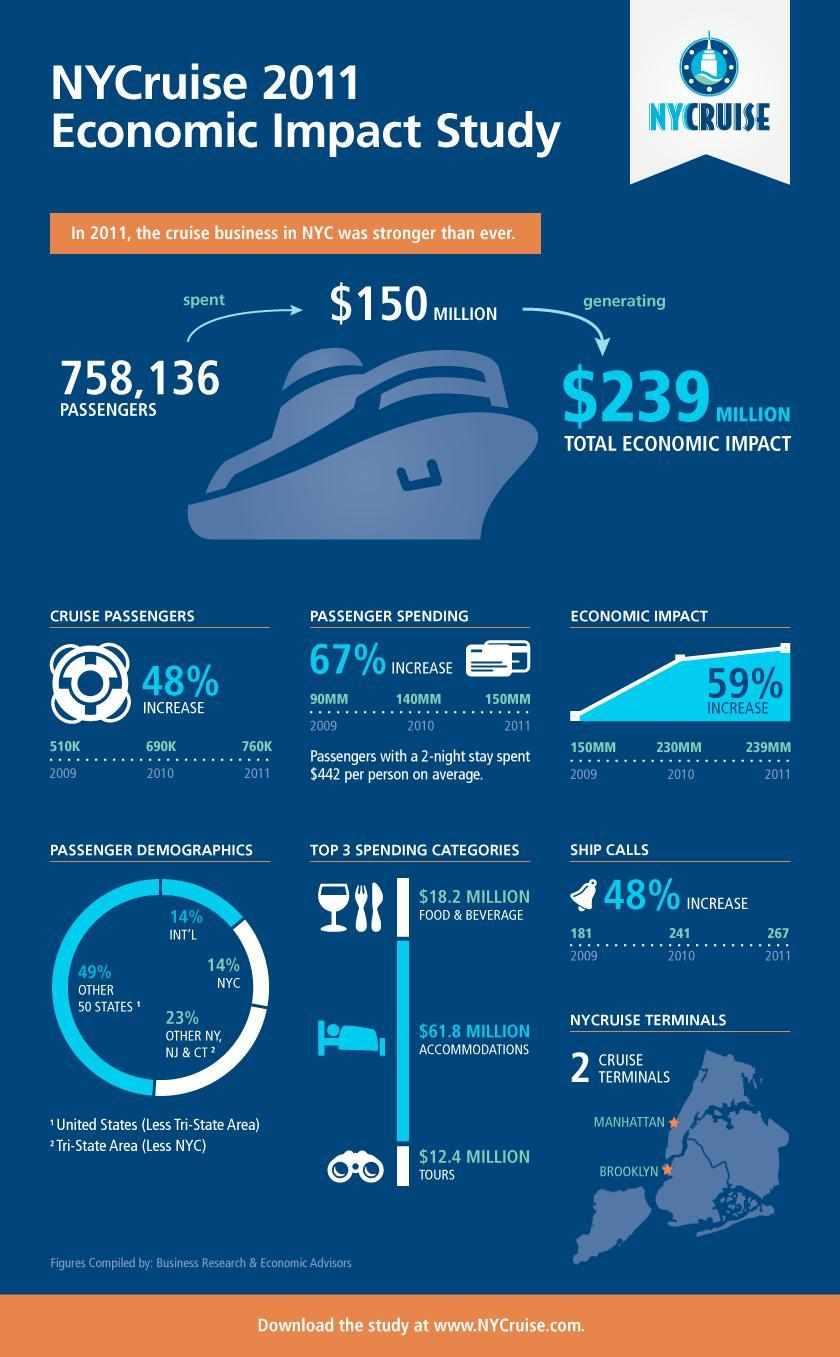What is the percentage increase of ship calls in cruise industry of New York City in 2011?
Answer the question with a short phrase. 48% What is the economic impact generated by cruise industry in 2010 for New York City? 230MM What is the economic impact generated by cruise industry in 2009 for New York City? 150MM How many ship calls were made in cruise industry of New York City in 2010? 241 What is the number of cruise passengers in 2010 in NYC? 690K What is the number of cruise passengers in 2009 in NYC? 510K 